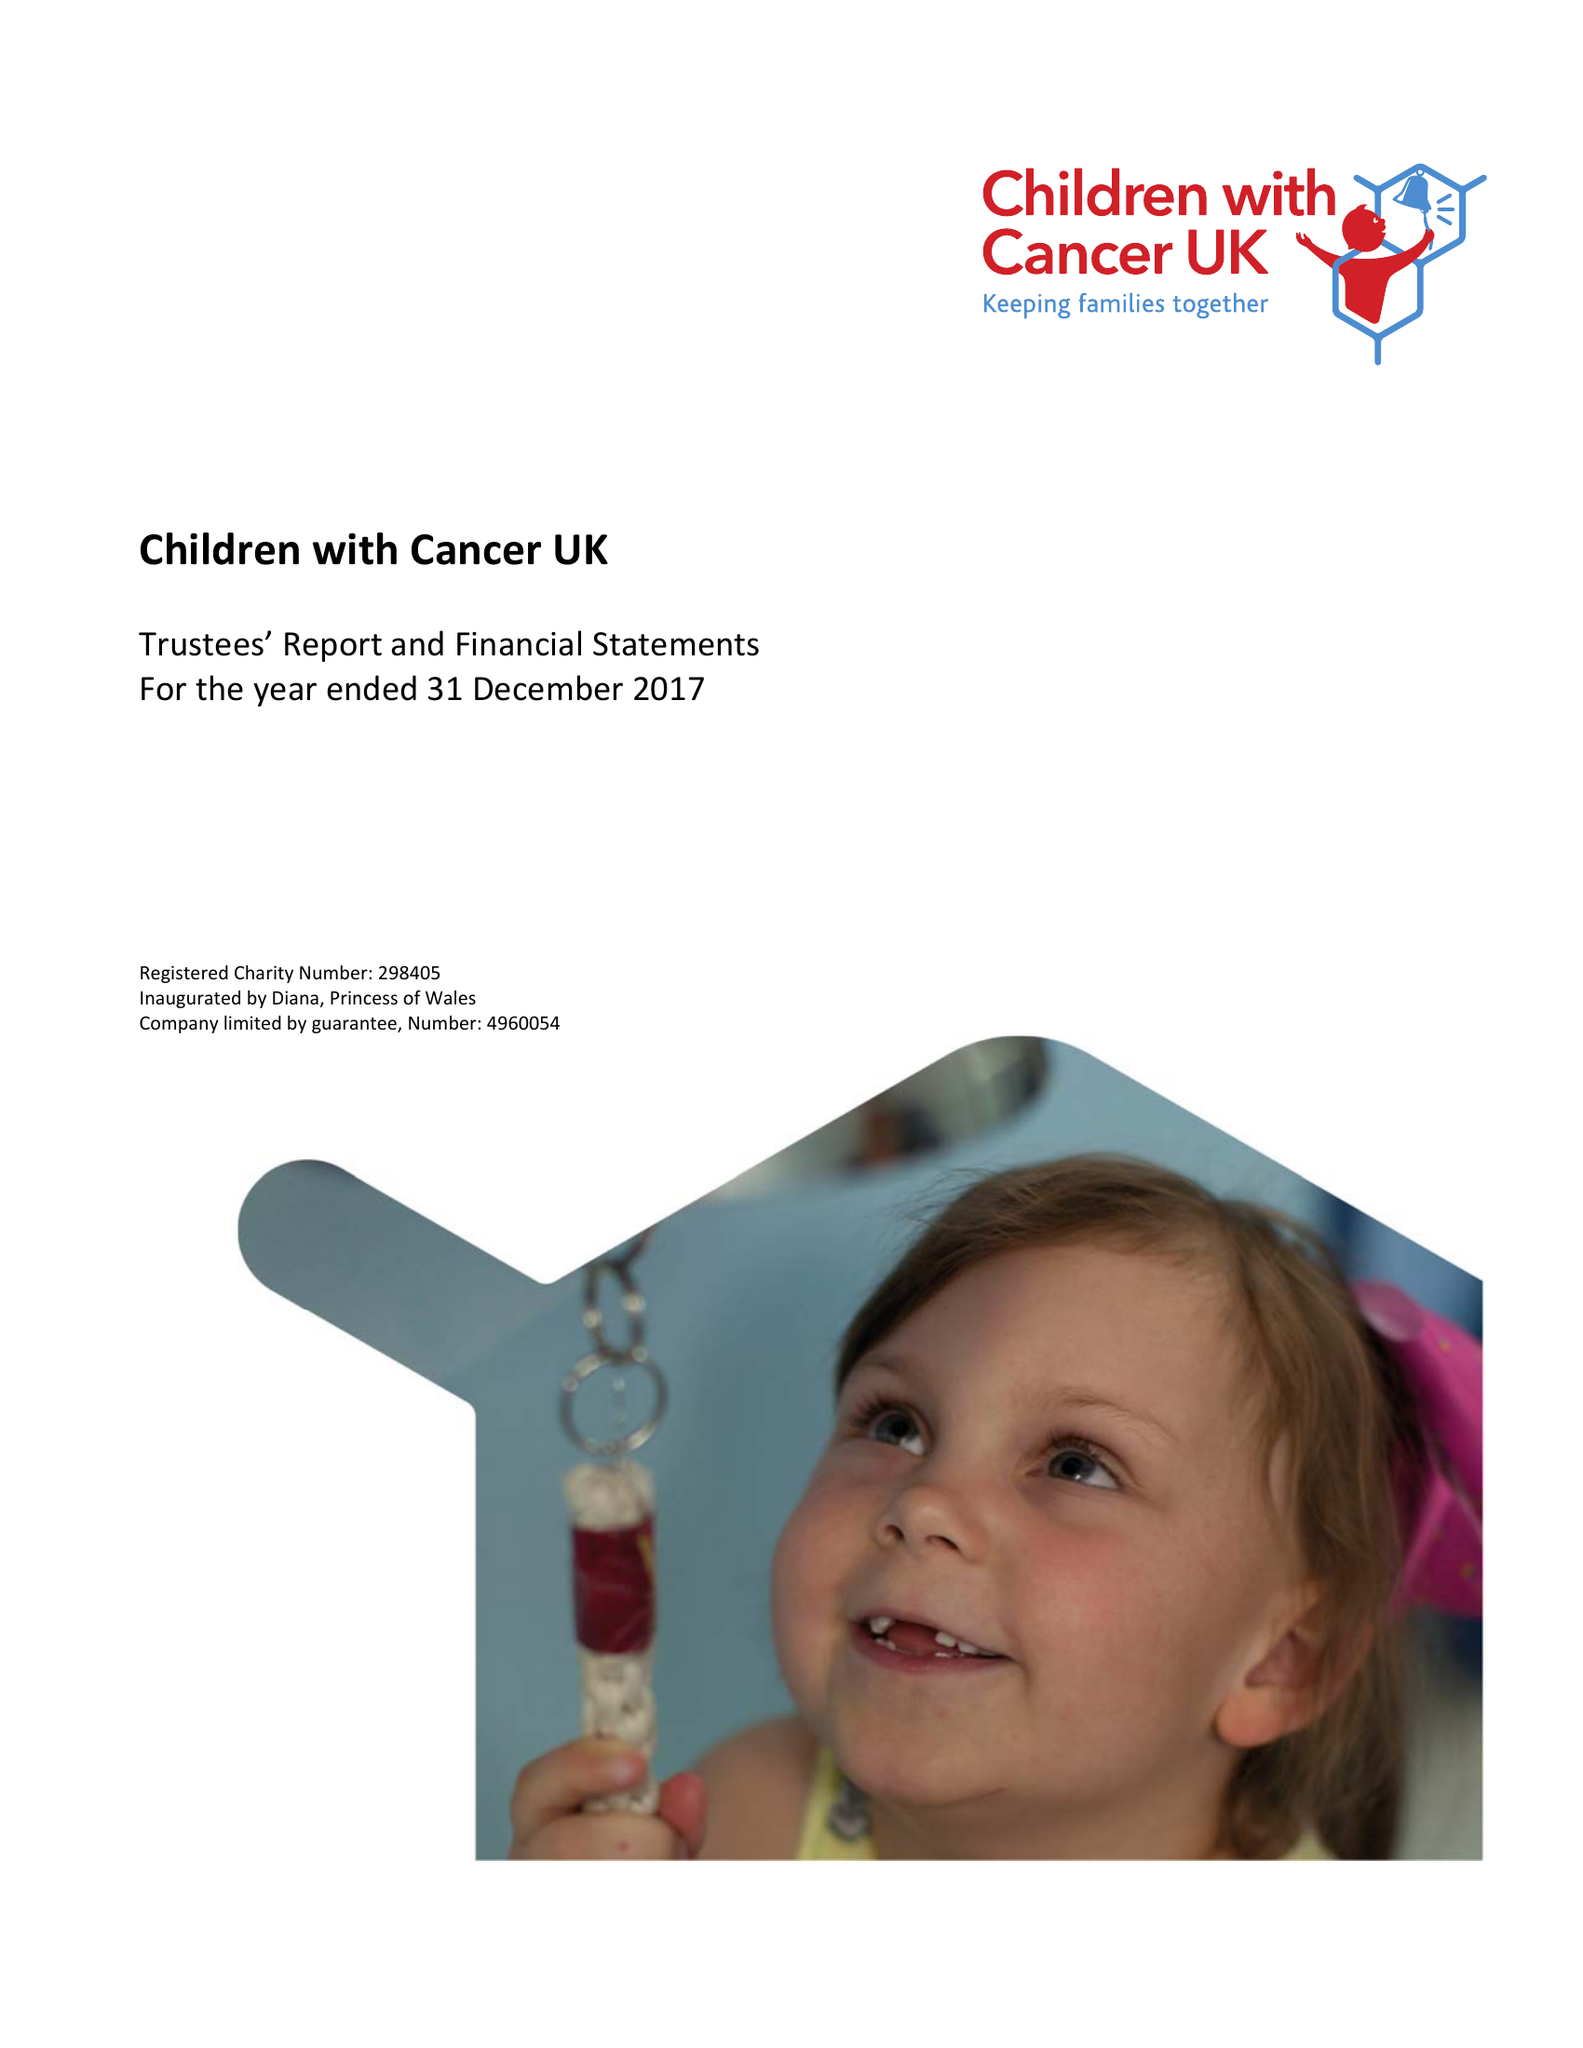What is the value for the income_annually_in_british_pounds?
Answer the question using a single word or phrase. 14332347.00 